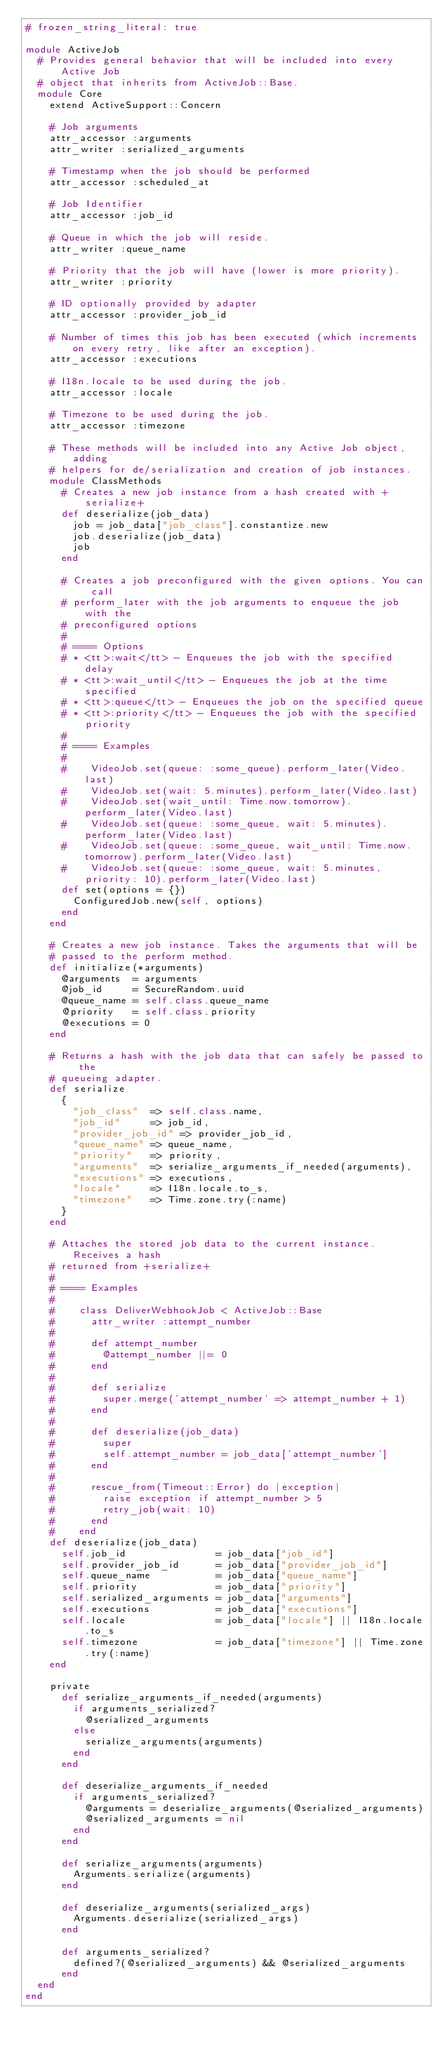<code> <loc_0><loc_0><loc_500><loc_500><_Ruby_># frozen_string_literal: true

module ActiveJob
  # Provides general behavior that will be included into every Active Job
  # object that inherits from ActiveJob::Base.
  module Core
    extend ActiveSupport::Concern

    # Job arguments
    attr_accessor :arguments
    attr_writer :serialized_arguments

    # Timestamp when the job should be performed
    attr_accessor :scheduled_at

    # Job Identifier
    attr_accessor :job_id

    # Queue in which the job will reside.
    attr_writer :queue_name

    # Priority that the job will have (lower is more priority).
    attr_writer :priority

    # ID optionally provided by adapter
    attr_accessor :provider_job_id

    # Number of times this job has been executed (which increments on every retry, like after an exception).
    attr_accessor :executions

    # I18n.locale to be used during the job.
    attr_accessor :locale

    # Timezone to be used during the job.
    attr_accessor :timezone

    # These methods will be included into any Active Job object, adding
    # helpers for de/serialization and creation of job instances.
    module ClassMethods
      # Creates a new job instance from a hash created with +serialize+
      def deserialize(job_data)
        job = job_data["job_class"].constantize.new
        job.deserialize(job_data)
        job
      end

      # Creates a job preconfigured with the given options. You can call
      # perform_later with the job arguments to enqueue the job with the
      # preconfigured options
      #
      # ==== Options
      # * <tt>:wait</tt> - Enqueues the job with the specified delay
      # * <tt>:wait_until</tt> - Enqueues the job at the time specified
      # * <tt>:queue</tt> - Enqueues the job on the specified queue
      # * <tt>:priority</tt> - Enqueues the job with the specified priority
      #
      # ==== Examples
      #
      #    VideoJob.set(queue: :some_queue).perform_later(Video.last)
      #    VideoJob.set(wait: 5.minutes).perform_later(Video.last)
      #    VideoJob.set(wait_until: Time.now.tomorrow).perform_later(Video.last)
      #    VideoJob.set(queue: :some_queue, wait: 5.minutes).perform_later(Video.last)
      #    VideoJob.set(queue: :some_queue, wait_until: Time.now.tomorrow).perform_later(Video.last)
      #    VideoJob.set(queue: :some_queue, wait: 5.minutes, priority: 10).perform_later(Video.last)
      def set(options = {})
        ConfiguredJob.new(self, options)
      end
    end

    # Creates a new job instance. Takes the arguments that will be
    # passed to the perform method.
    def initialize(*arguments)
      @arguments  = arguments
      @job_id     = SecureRandom.uuid
      @queue_name = self.class.queue_name
      @priority   = self.class.priority
      @executions = 0
    end

    # Returns a hash with the job data that can safely be passed to the
    # queueing adapter.
    def serialize
      {
        "job_class"  => self.class.name,
        "job_id"     => job_id,
        "provider_job_id" => provider_job_id,
        "queue_name" => queue_name,
        "priority"   => priority,
        "arguments"  => serialize_arguments_if_needed(arguments),
        "executions" => executions,
        "locale"     => I18n.locale.to_s,
        "timezone"   => Time.zone.try(:name)
      }
    end

    # Attaches the stored job data to the current instance. Receives a hash
    # returned from +serialize+
    #
    # ==== Examples
    #
    #    class DeliverWebhookJob < ActiveJob::Base
    #      attr_writer :attempt_number
    #
    #      def attempt_number
    #        @attempt_number ||= 0
    #      end
    #
    #      def serialize
    #        super.merge('attempt_number' => attempt_number + 1)
    #      end
    #
    #      def deserialize(job_data)
    #        super
    #        self.attempt_number = job_data['attempt_number']
    #      end
    #
    #      rescue_from(Timeout::Error) do |exception|
    #        raise exception if attempt_number > 5
    #        retry_job(wait: 10)
    #      end
    #    end
    def deserialize(job_data)
      self.job_id               = job_data["job_id"]
      self.provider_job_id      = job_data["provider_job_id"]
      self.queue_name           = job_data["queue_name"]
      self.priority             = job_data["priority"]
      self.serialized_arguments = job_data["arguments"]
      self.executions           = job_data["executions"]
      self.locale               = job_data["locale"] || I18n.locale.to_s
      self.timezone             = job_data["timezone"] || Time.zone.try(:name)
    end

    private
      def serialize_arguments_if_needed(arguments)
        if arguments_serialized?
          @serialized_arguments
        else
          serialize_arguments(arguments)
        end
      end

      def deserialize_arguments_if_needed
        if arguments_serialized?
          @arguments = deserialize_arguments(@serialized_arguments)
          @serialized_arguments = nil
        end
      end

      def serialize_arguments(arguments)
        Arguments.serialize(arguments)
      end

      def deserialize_arguments(serialized_args)
        Arguments.deserialize(serialized_args)
      end

      def arguments_serialized?
        defined?(@serialized_arguments) && @serialized_arguments
      end
  end
end
</code> 